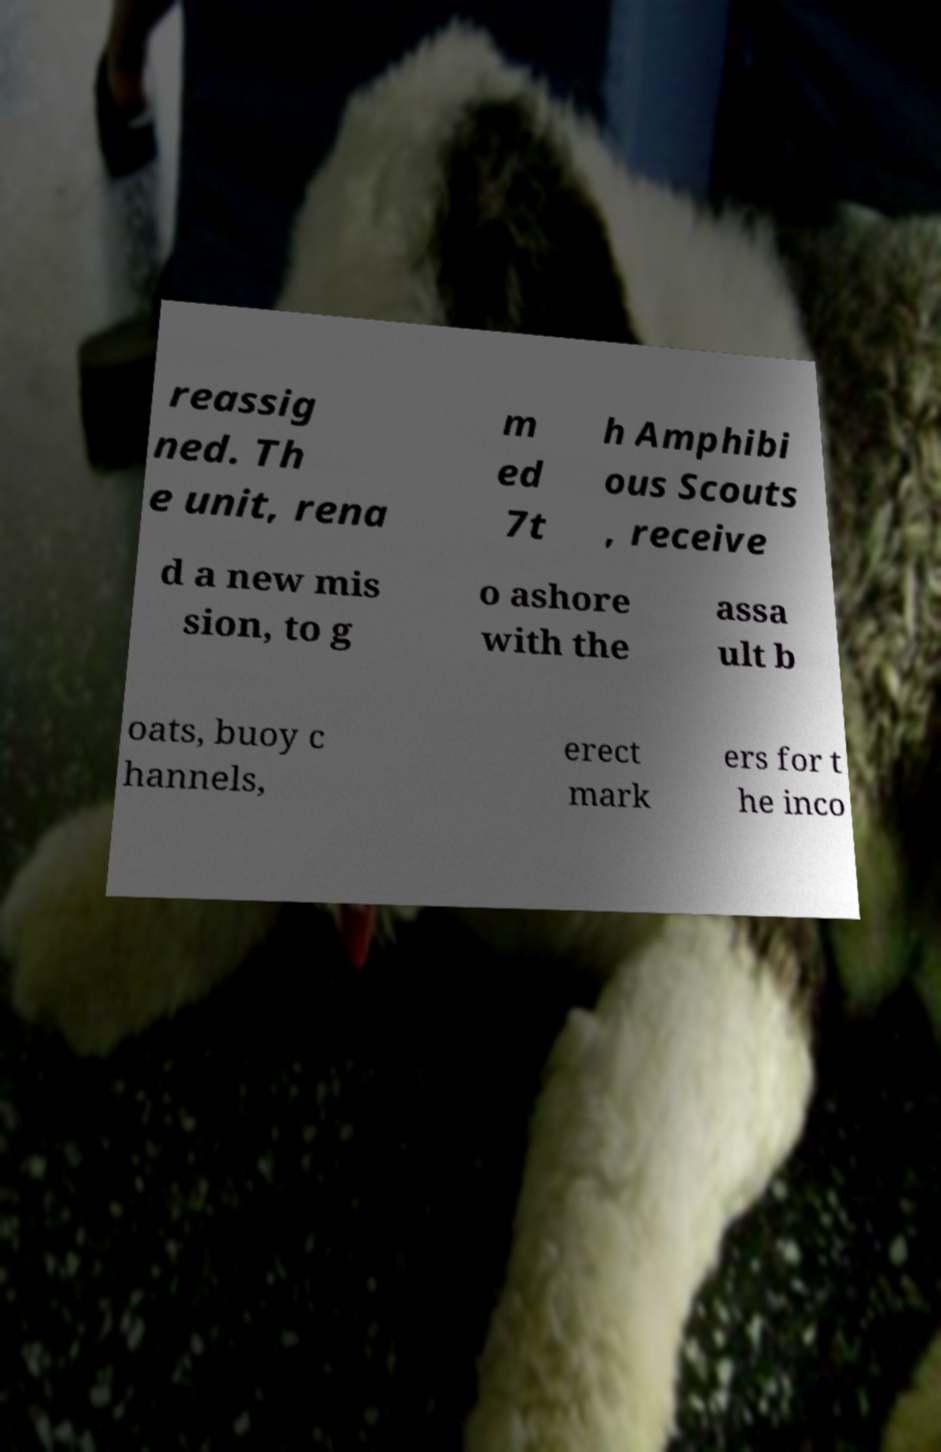Could you assist in decoding the text presented in this image and type it out clearly? reassig ned. Th e unit, rena m ed 7t h Amphibi ous Scouts , receive d a new mis sion, to g o ashore with the assa ult b oats, buoy c hannels, erect mark ers for t he inco 